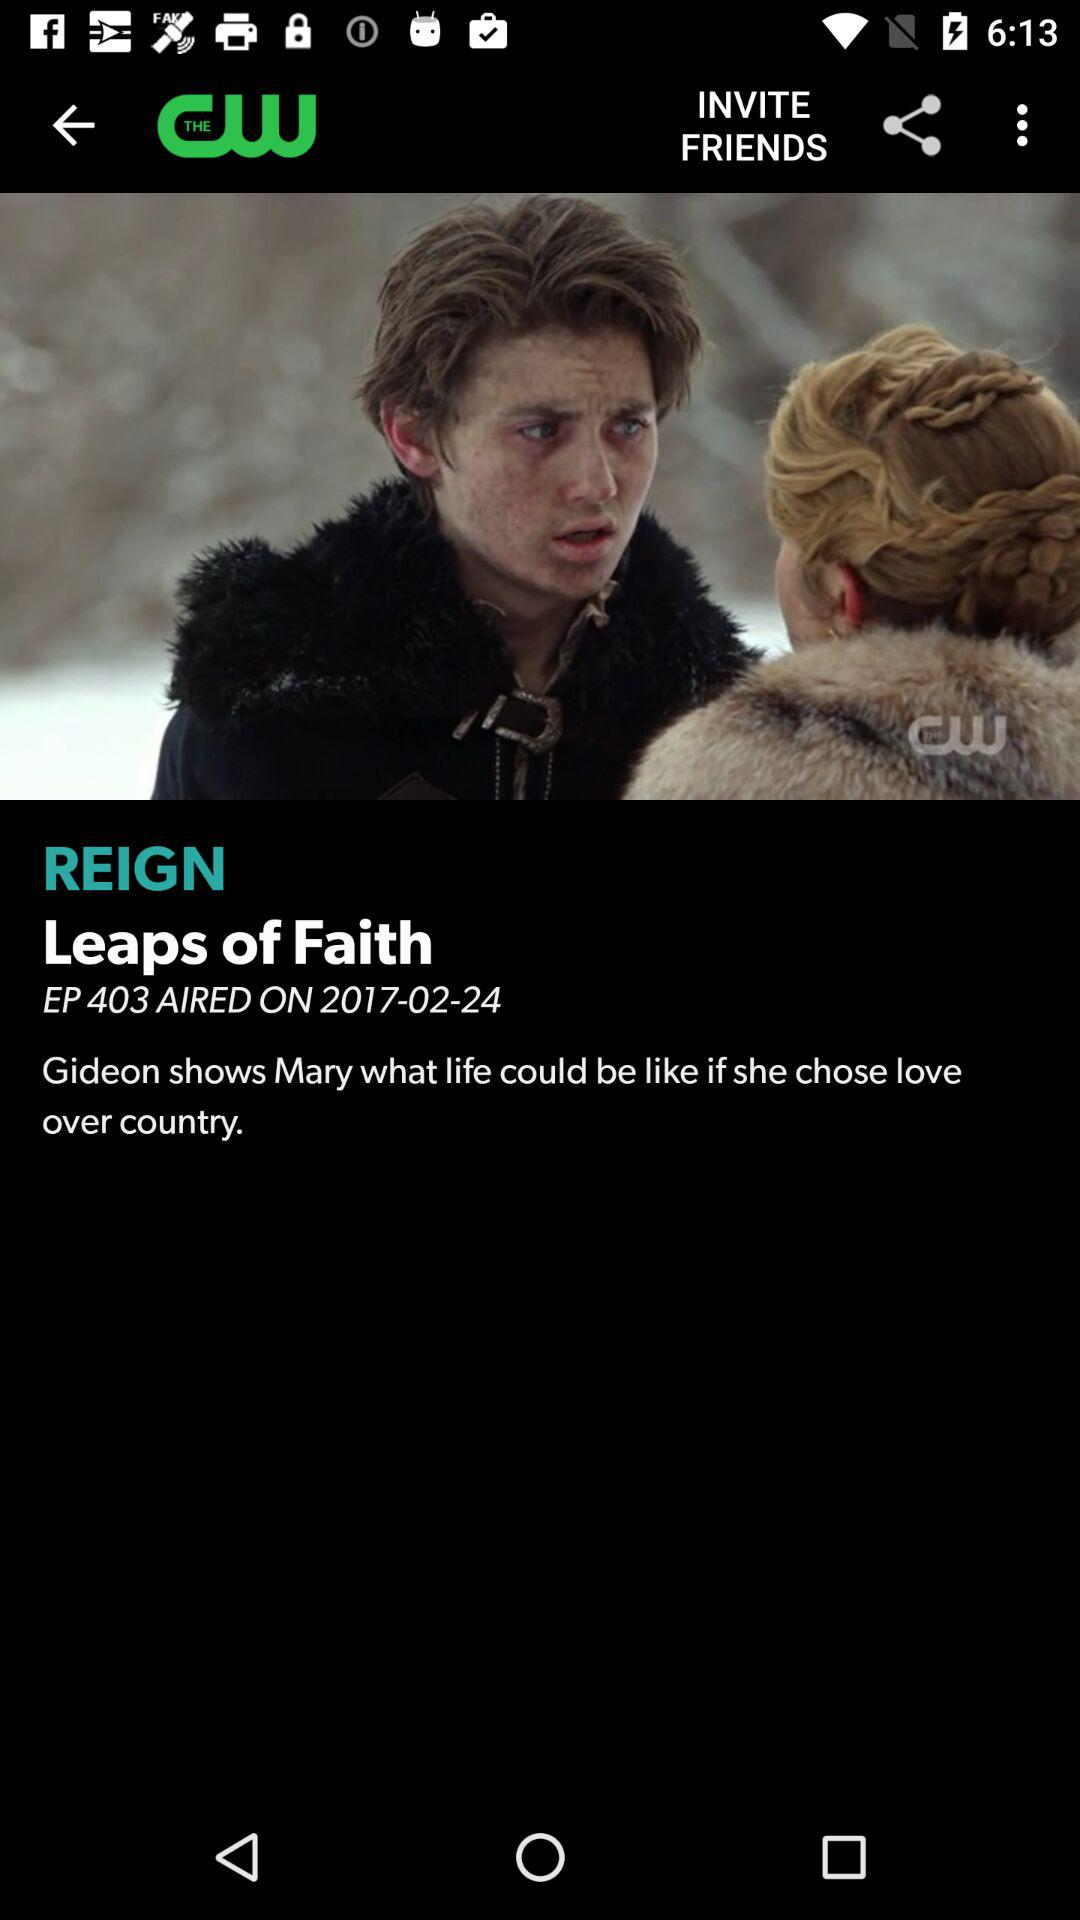What is the name of the application? The name of the application is "THE CW". 